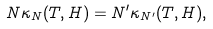<formula> <loc_0><loc_0><loc_500><loc_500>N \kappa _ { N } ( T , H ) = N ^ { \prime } \kappa _ { N ^ { \prime } } ( T , H ) ,</formula> 